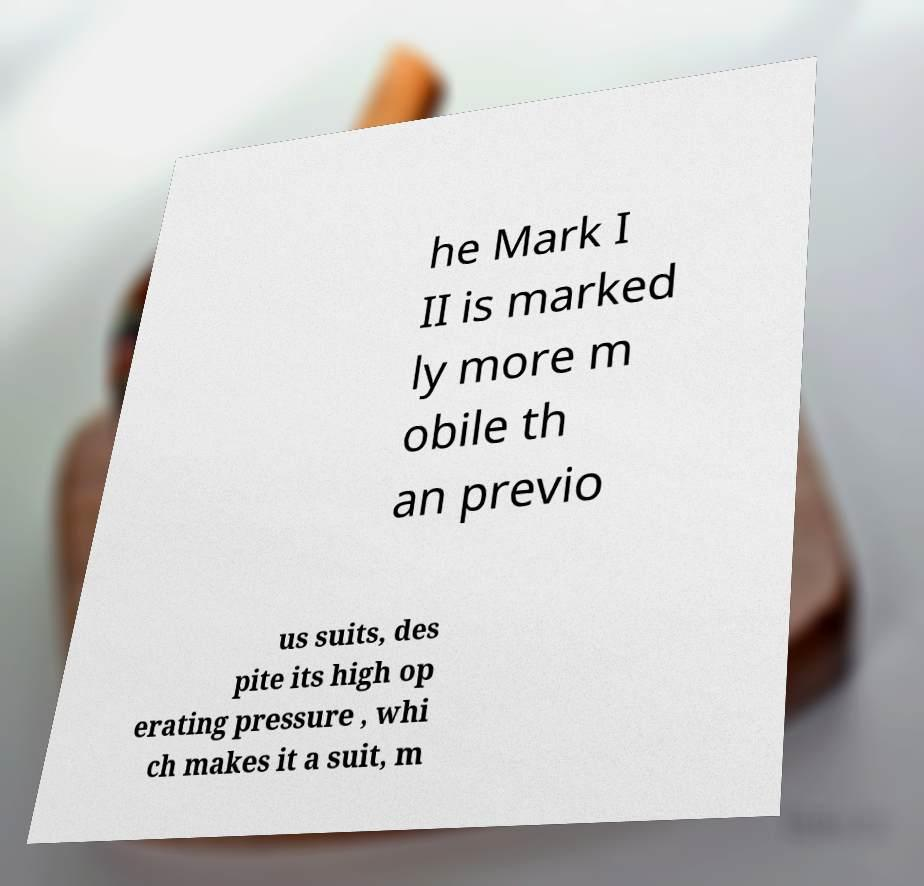Please read and relay the text visible in this image. What does it say? he Mark I II is marked ly more m obile th an previo us suits, des pite its high op erating pressure , whi ch makes it a suit, m 